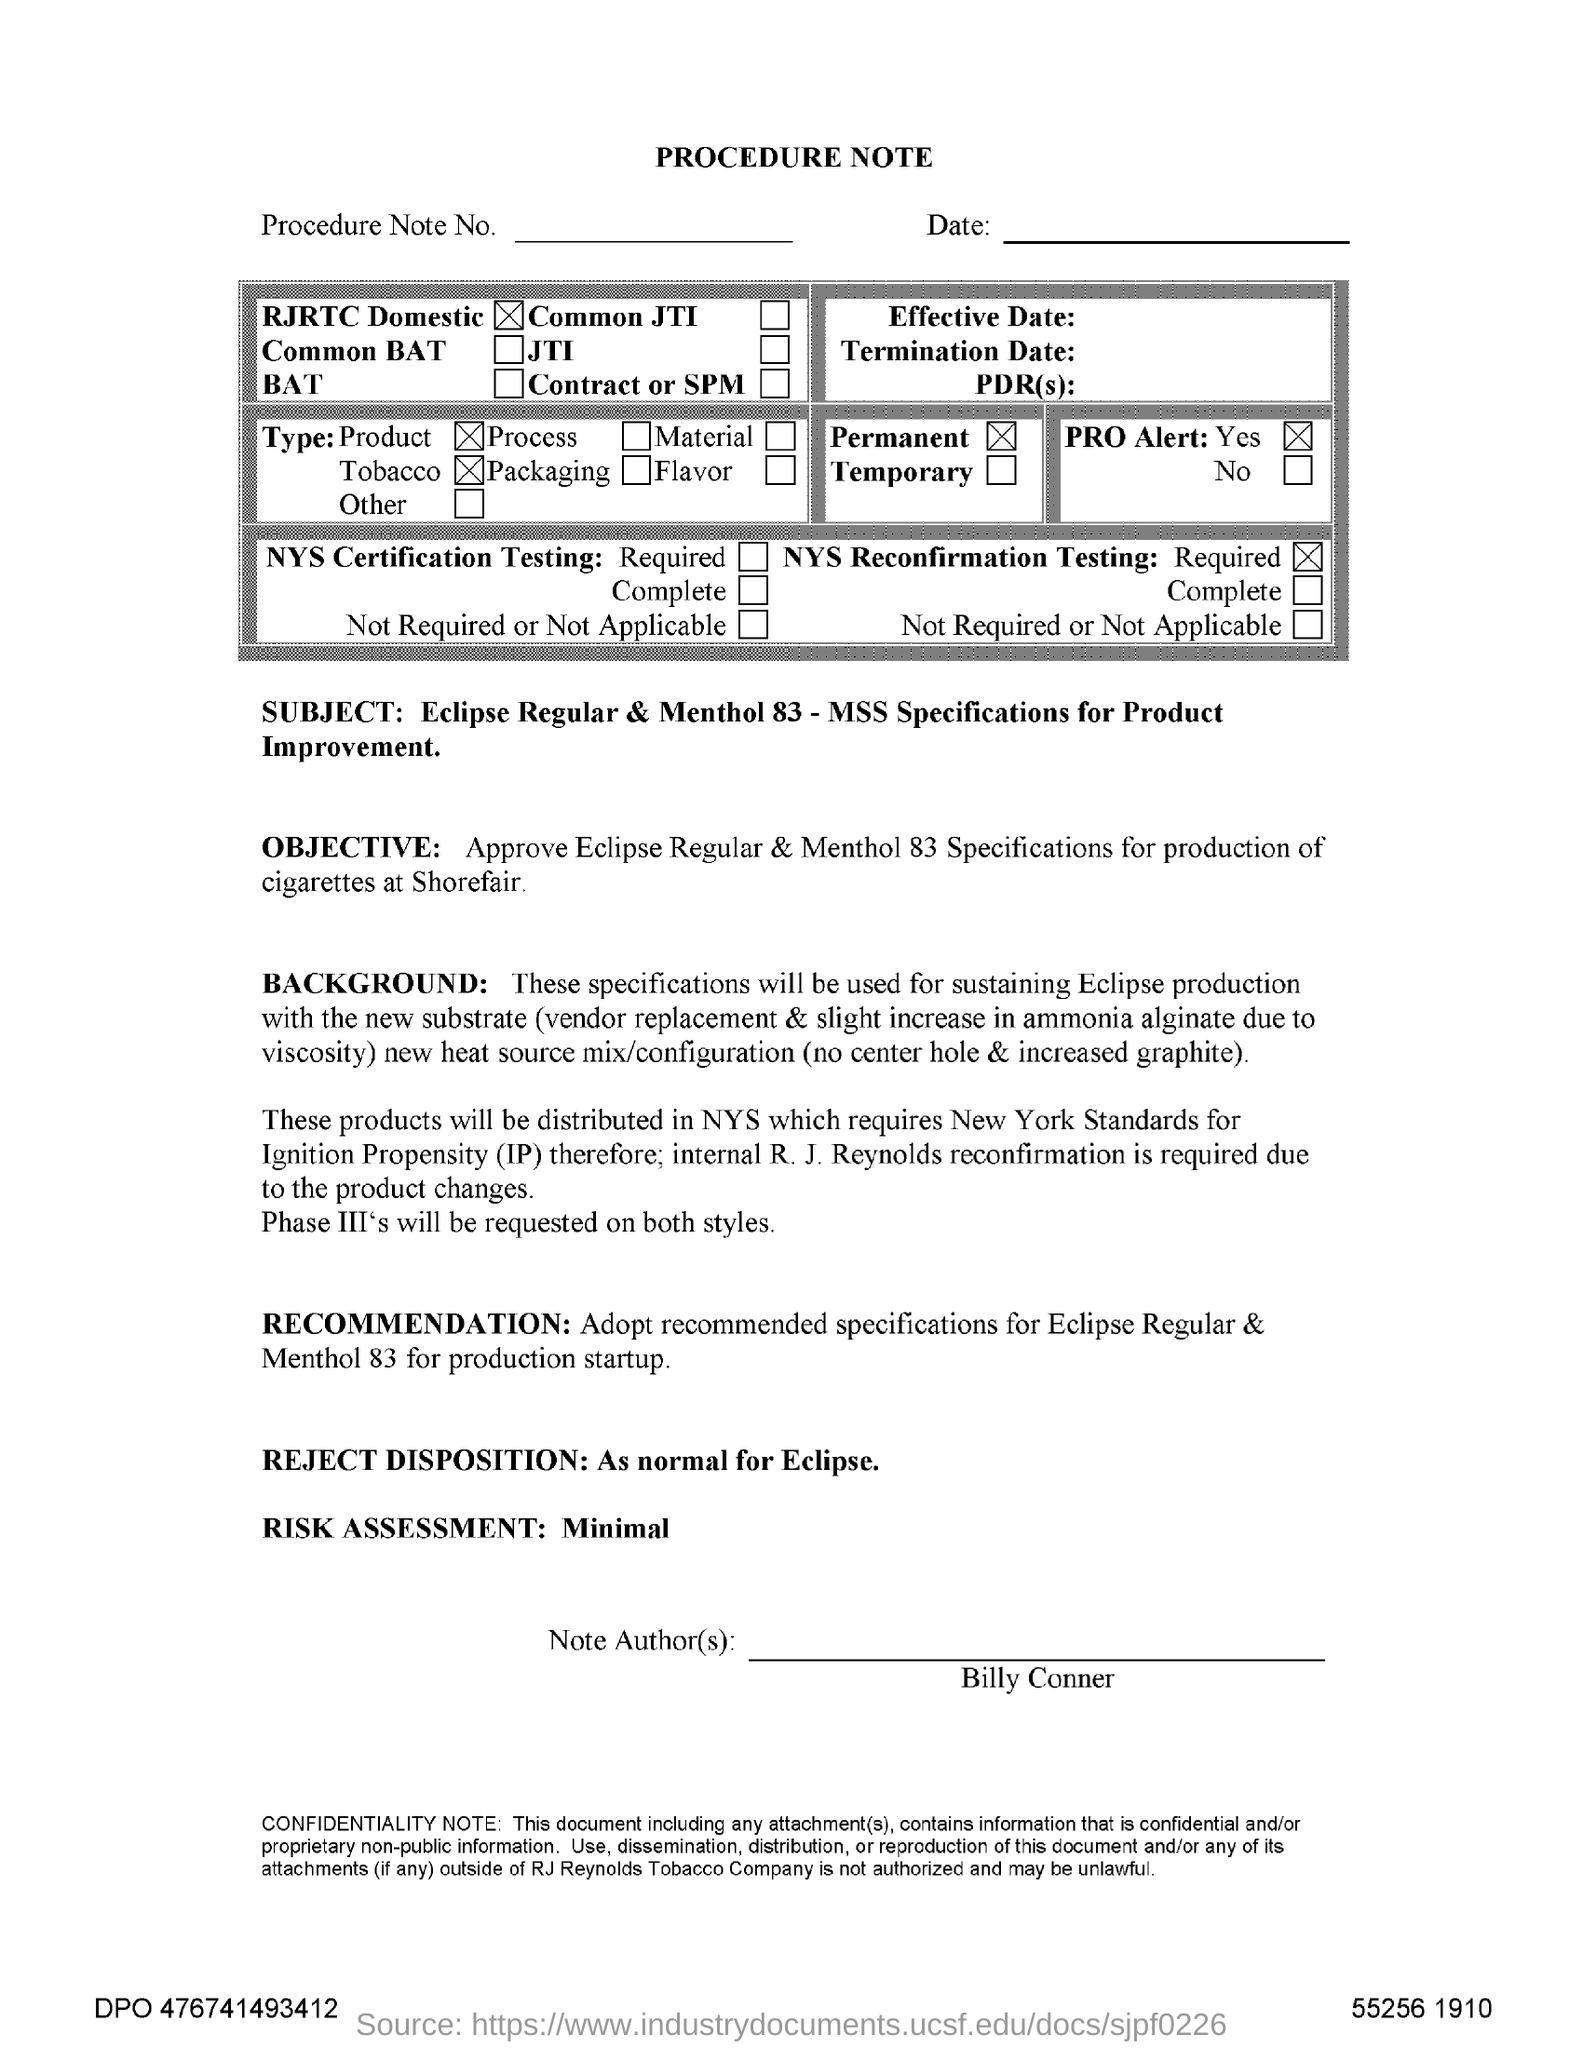Highlight a few significant elements in this photo. The reject disposition, when processed as normal in Eclipse, results in... The risk assessment is minimal. Billy Conner is the note author. 